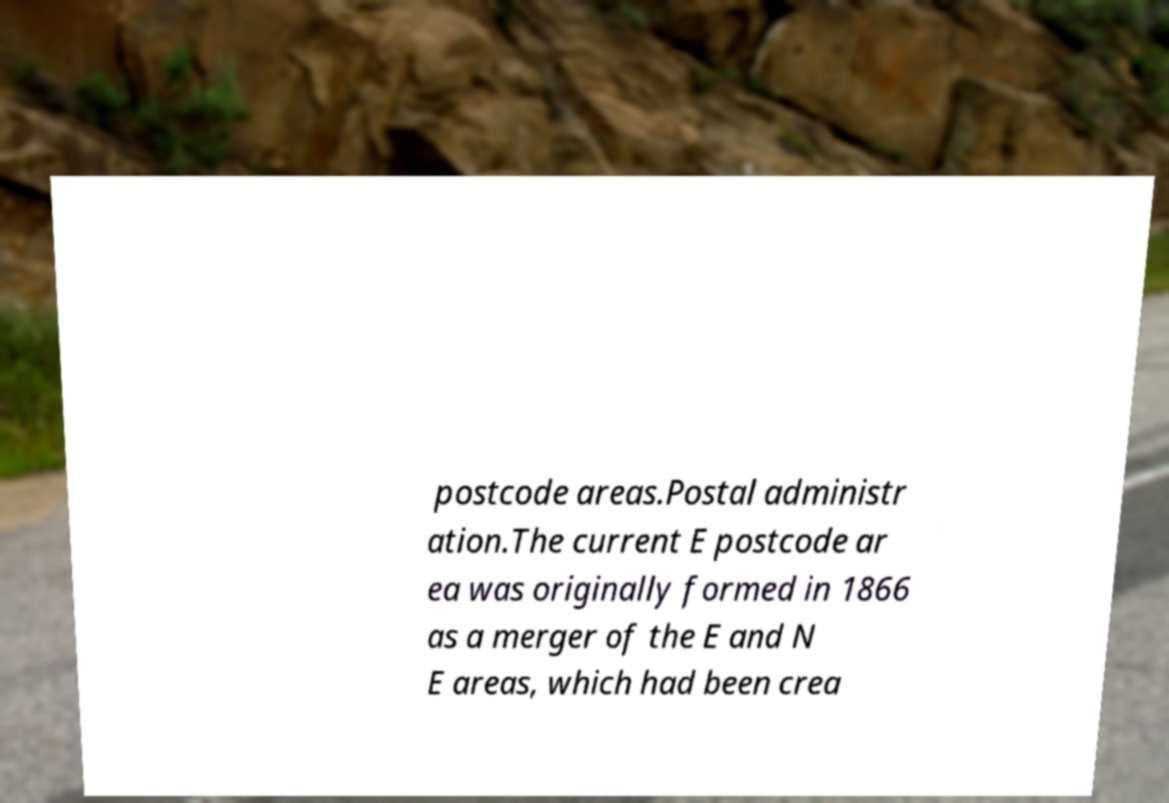Please read and relay the text visible in this image. What does it say? postcode areas.Postal administr ation.The current E postcode ar ea was originally formed in 1866 as a merger of the E and N E areas, which had been crea 